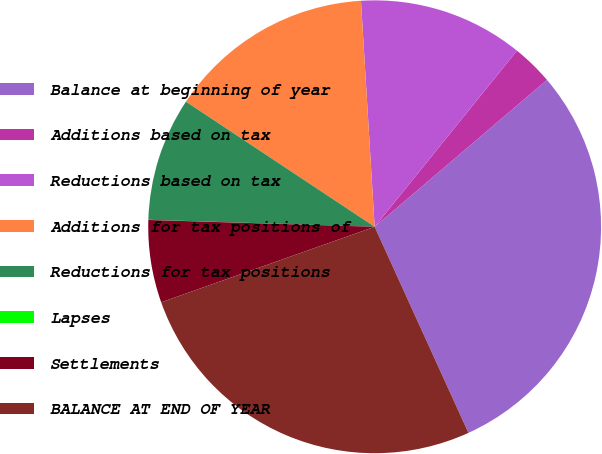<chart> <loc_0><loc_0><loc_500><loc_500><pie_chart><fcel>Balance at beginning of year<fcel>Additions based on tax<fcel>Reductions based on tax<fcel>Additions for tax positions of<fcel>Reductions for tax positions<fcel>Lapses<fcel>Settlements<fcel>BALANCE AT END OF YEAR<nl><fcel>29.44%<fcel>2.95%<fcel>11.78%<fcel>14.72%<fcel>8.83%<fcel>0.01%<fcel>5.89%<fcel>26.39%<nl></chart> 